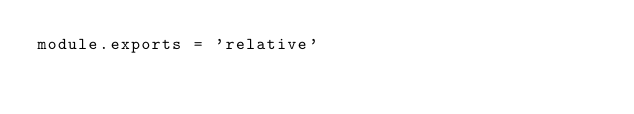<code> <loc_0><loc_0><loc_500><loc_500><_JavaScript_>module.exports = 'relative'
</code> 